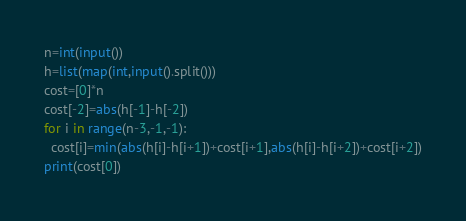Convert code to text. <code><loc_0><loc_0><loc_500><loc_500><_Python_>n=int(input())
h=list(map(int,input().split()))
cost=[0]*n
cost[-2]=abs(h[-1]-h[-2])
for i in range(n-3,-1,-1):
  cost[i]=min(abs(h[i]-h[i+1])+cost[i+1],abs(h[i]-h[i+2])+cost[i+2])
print(cost[0])</code> 